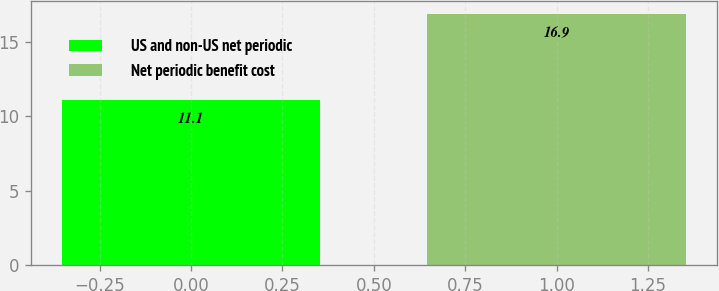Convert chart to OTSL. <chart><loc_0><loc_0><loc_500><loc_500><bar_chart><fcel>US and non-US net periodic<fcel>Net periodic benefit cost<nl><fcel>11.1<fcel>16.9<nl></chart> 